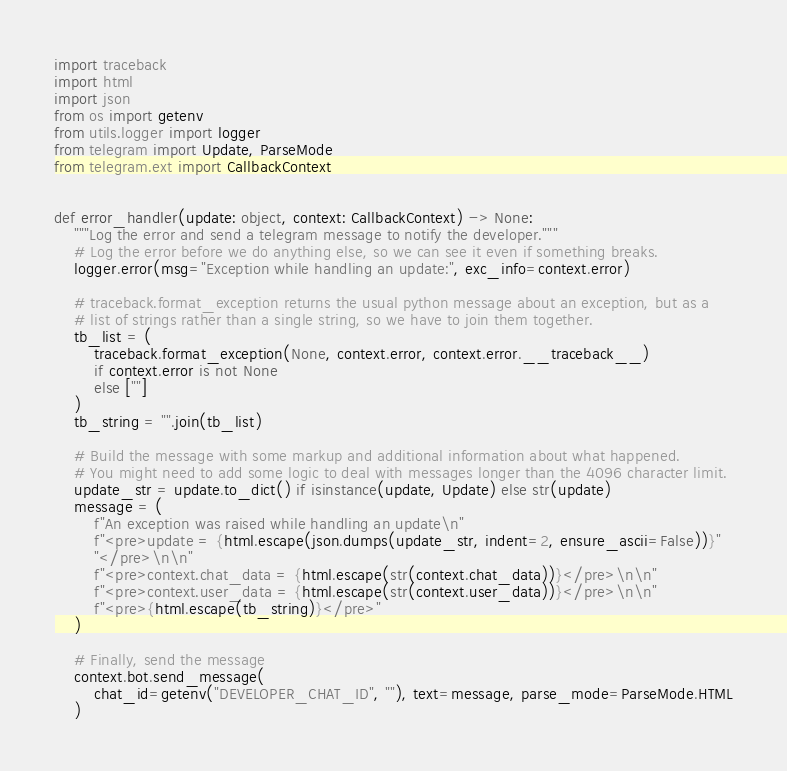<code> <loc_0><loc_0><loc_500><loc_500><_Python_>import traceback
import html
import json
from os import getenv
from utils.logger import logger
from telegram import Update, ParseMode
from telegram.ext import CallbackContext


def error_handler(update: object, context: CallbackContext) -> None:
    """Log the error and send a telegram message to notify the developer."""
    # Log the error before we do anything else, so we can see it even if something breaks.
    logger.error(msg="Exception while handling an update:", exc_info=context.error)

    # traceback.format_exception returns the usual python message about an exception, but as a
    # list of strings rather than a single string, so we have to join them together.
    tb_list = (
        traceback.format_exception(None, context.error, context.error.__traceback__)
        if context.error is not None
        else [""]
    )
    tb_string = "".join(tb_list)

    # Build the message with some markup and additional information about what happened.
    # You might need to add some logic to deal with messages longer than the 4096 character limit.
    update_str = update.to_dict() if isinstance(update, Update) else str(update)
    message = (
        f"An exception was raised while handling an update\n"
        f"<pre>update = {html.escape(json.dumps(update_str, indent=2, ensure_ascii=False))}"
        "</pre>\n\n"
        f"<pre>context.chat_data = {html.escape(str(context.chat_data))}</pre>\n\n"
        f"<pre>context.user_data = {html.escape(str(context.user_data))}</pre>\n\n"
        f"<pre>{html.escape(tb_string)}</pre>"
    )

    # Finally, send the message
    context.bot.send_message(
        chat_id=getenv("DEVELOPER_CHAT_ID", ""), text=message, parse_mode=ParseMode.HTML
    )
</code> 